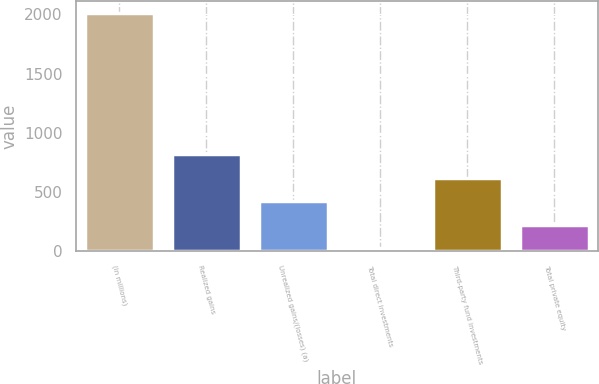<chart> <loc_0><loc_0><loc_500><loc_500><bar_chart><fcel>(in millions)<fcel>Realized gains<fcel>Unrealized gains/(losses) (a)<fcel>Total direct investments<fcel>Third-party fund investments<fcel>Total private equity<nl><fcel>2009<fcel>820.4<fcel>424.2<fcel>28<fcel>622.3<fcel>226.1<nl></chart> 